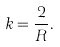Convert formula to latex. <formula><loc_0><loc_0><loc_500><loc_500>k = \frac { 2 } { R } .</formula> 